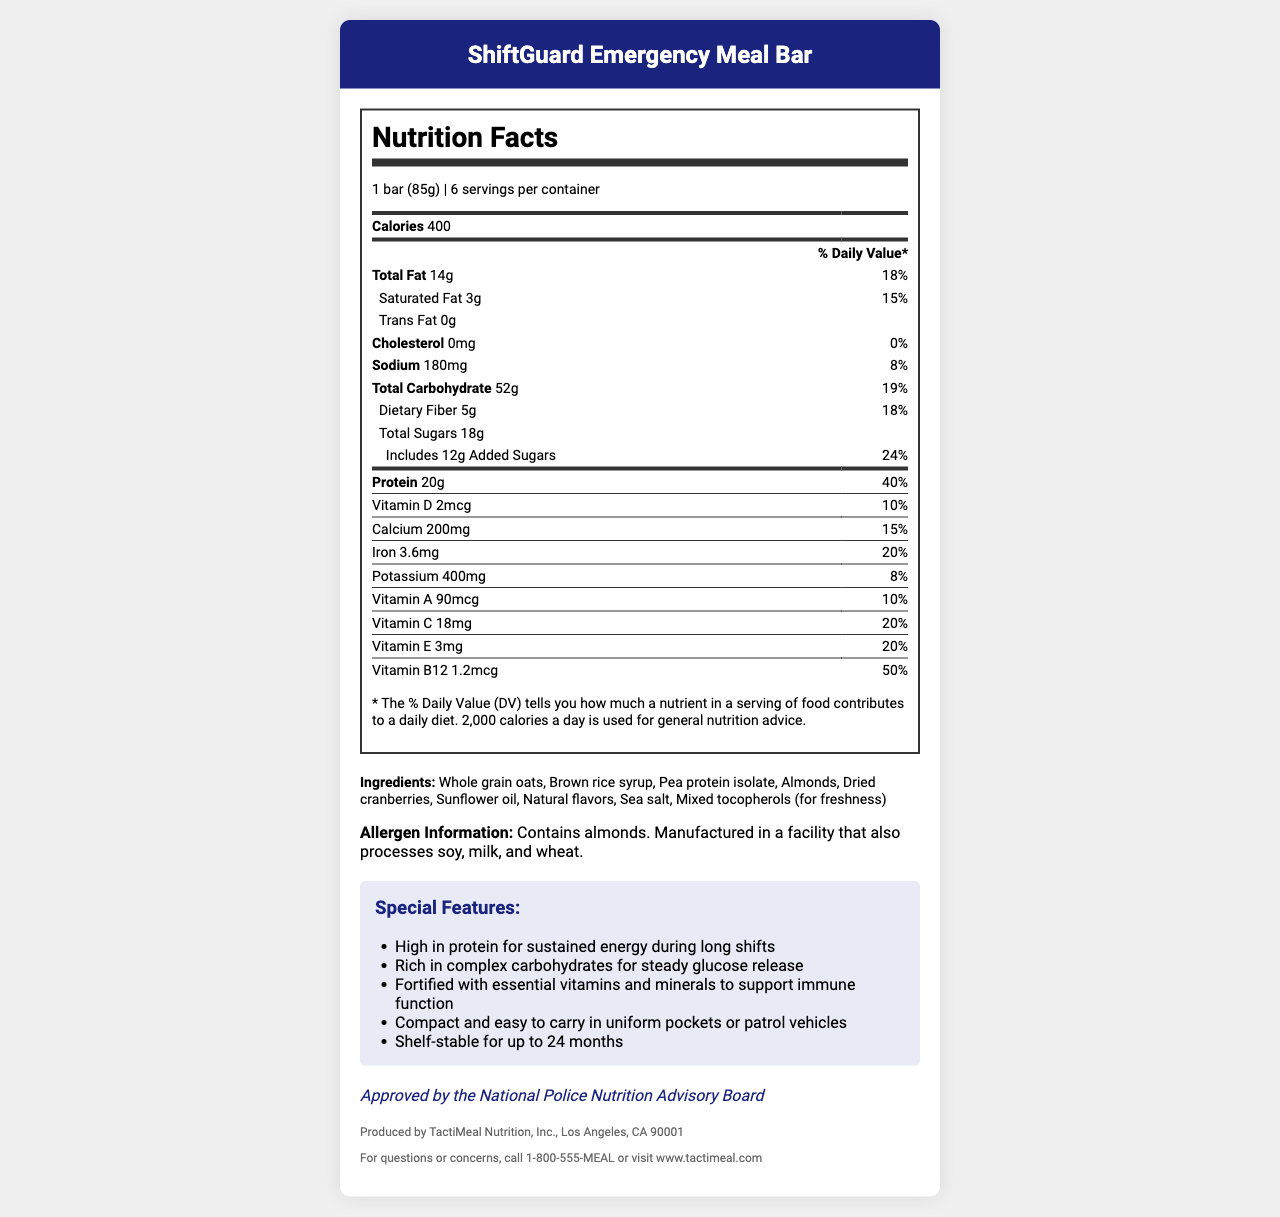what is the serving size of ShiftGuard Emergency Meal Bar? The serving size information is directly stated at the top of the nutrition facts section.
Answer: 1 bar (85g) how many calories are in one serving of the meal bar? The calories per serving are listed in the nutrition facts section under "Calories".
Answer: 400 what is the source of protein in the ShiftGuard Emergency Meal Bar? The protein source is found in the list of ingredients.
Answer: Pea protein isolate what is the shelf life of these meal bars? The shelf-stable feature is mentioned in the special features section.
Answer: Up to 24 months What is the percentage of daily value for Vitamin B12 in one serving? The daily value percentage for Vitamin B12 is listed in the nutrition facts under the Vitamin B12 section.
Answer: 50% Which of the following allergens are present in the ShiftGuard Emergency Meal Bar? A. Peanuts B. Almonds C. Soy D. Dairy The allergen information clearly states that the product contains almonds.
Answer: B. Almonds What are the main benefits of the ShiftGuard Emergency Meal Bar for police officers? i. High in protein ii. Quick energy boost iii. Rich in complex carbohydrates iv. Supports immune function The special features section mentions the benefits like high protein content, complex carbohydrates, and essential vitamins/minerals for immune support. Quick energy boost is not mentioned.
Answer: i. High in protein, iii. Rich in complex carbohydrates, iv. Supports immune function does the meal bar contain any cholesterol? The nutrition facts section shows 0mg of cholesterol, which means the product contains no cholesterol.
Answer: No Summarize the main features of the ShiftGuard Emergency Meal Bar. The summary includes a broad overview of the nutritional content, special features, and endorsement details.
Answer: The ShiftGuard Emergency Meal Bar is a high-protein, nutrient-rich meal replacement bar designed for police officers. Each bar contains 400 calories and is fortified with essential vitamins and minerals. It is compact, shelf-stable for up to 24 months, and contains almonds. It is endorsed by the National Police Nutrition Advisory Board. How many grams of total carbohydrate are in two bars? Each bar contains 52g of total carbohydrates. Therefore, two bars contain 52g x 2 = 104g of total carbohydrates.
Answer: 104g what is the purpose of mixed tocopherols in the ingredient list? The reason for adding mixed tocopherols is not explained within the document, though they are generally used for freshness.
Answer: Not enough information 